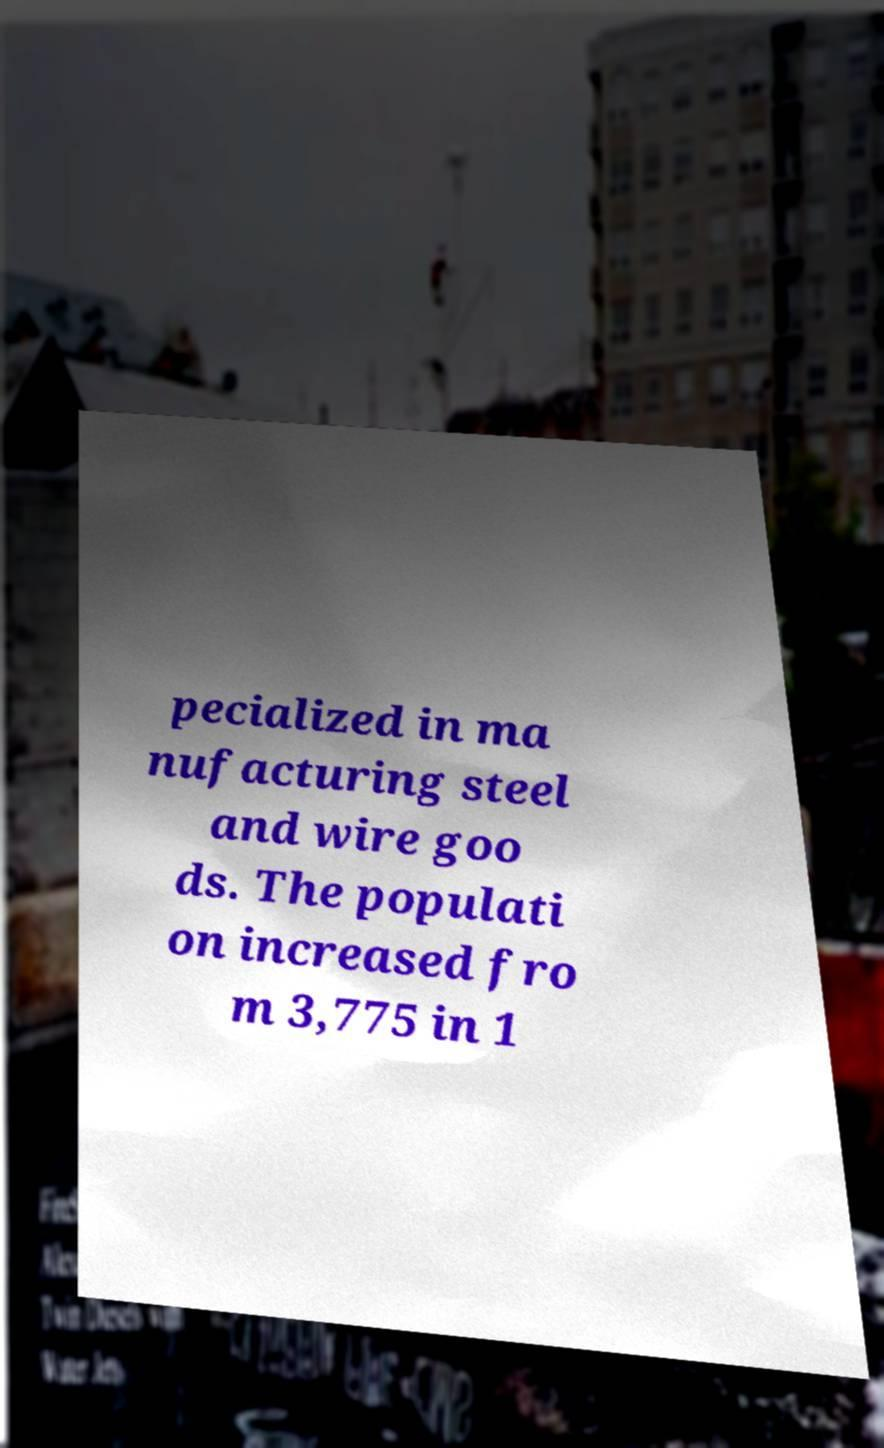Please identify and transcribe the text found in this image. pecialized in ma nufacturing steel and wire goo ds. The populati on increased fro m 3,775 in 1 